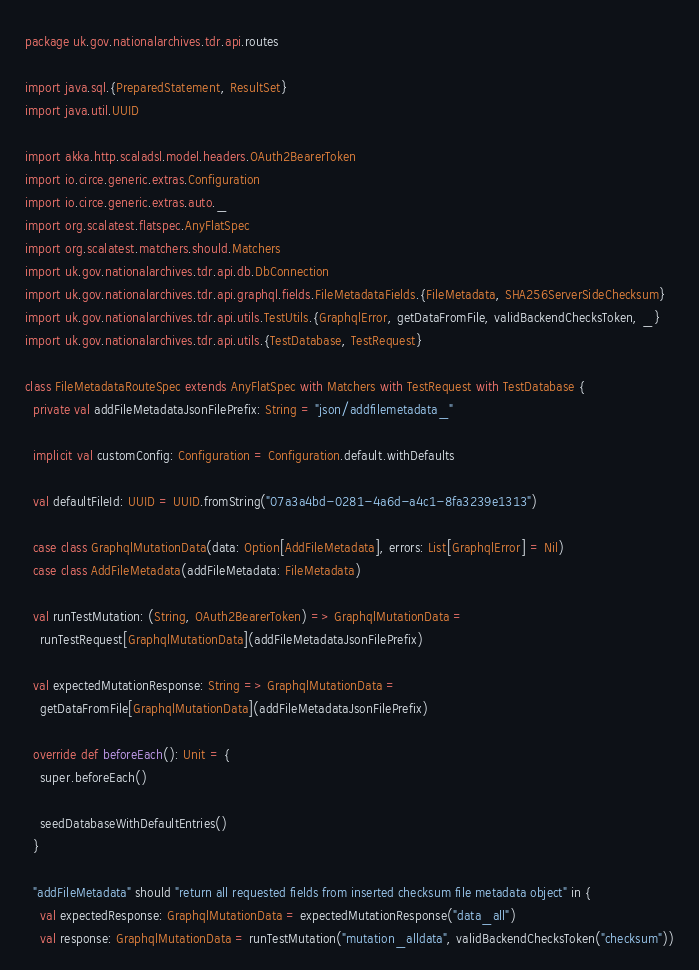Convert code to text. <code><loc_0><loc_0><loc_500><loc_500><_Scala_>package uk.gov.nationalarchives.tdr.api.routes

import java.sql.{PreparedStatement, ResultSet}
import java.util.UUID

import akka.http.scaladsl.model.headers.OAuth2BearerToken
import io.circe.generic.extras.Configuration
import io.circe.generic.extras.auto._
import org.scalatest.flatspec.AnyFlatSpec
import org.scalatest.matchers.should.Matchers
import uk.gov.nationalarchives.tdr.api.db.DbConnection
import uk.gov.nationalarchives.tdr.api.graphql.fields.FileMetadataFields.{FileMetadata, SHA256ServerSideChecksum}
import uk.gov.nationalarchives.tdr.api.utils.TestUtils.{GraphqlError, getDataFromFile, validBackendChecksToken, _}
import uk.gov.nationalarchives.tdr.api.utils.{TestDatabase, TestRequest}

class FileMetadataRouteSpec extends AnyFlatSpec with Matchers with TestRequest with TestDatabase {
  private val addFileMetadataJsonFilePrefix: String = "json/addfilemetadata_"

  implicit val customConfig: Configuration = Configuration.default.withDefaults

  val defaultFileId: UUID = UUID.fromString("07a3a4bd-0281-4a6d-a4c1-8fa3239e1313")

  case class GraphqlMutationData(data: Option[AddFileMetadata], errors: List[GraphqlError] = Nil)
  case class AddFileMetadata(addFileMetadata: FileMetadata)

  val runTestMutation: (String, OAuth2BearerToken) => GraphqlMutationData =
    runTestRequest[GraphqlMutationData](addFileMetadataJsonFilePrefix)

  val expectedMutationResponse: String => GraphqlMutationData =
    getDataFromFile[GraphqlMutationData](addFileMetadataJsonFilePrefix)

  override def beforeEach(): Unit = {
    super.beforeEach()

    seedDatabaseWithDefaultEntries()
  }

  "addFileMetadata" should "return all requested fields from inserted checksum file metadata object" in {
    val expectedResponse: GraphqlMutationData = expectedMutationResponse("data_all")
    val response: GraphqlMutationData = runTestMutation("mutation_alldata", validBackendChecksToken("checksum"))</code> 